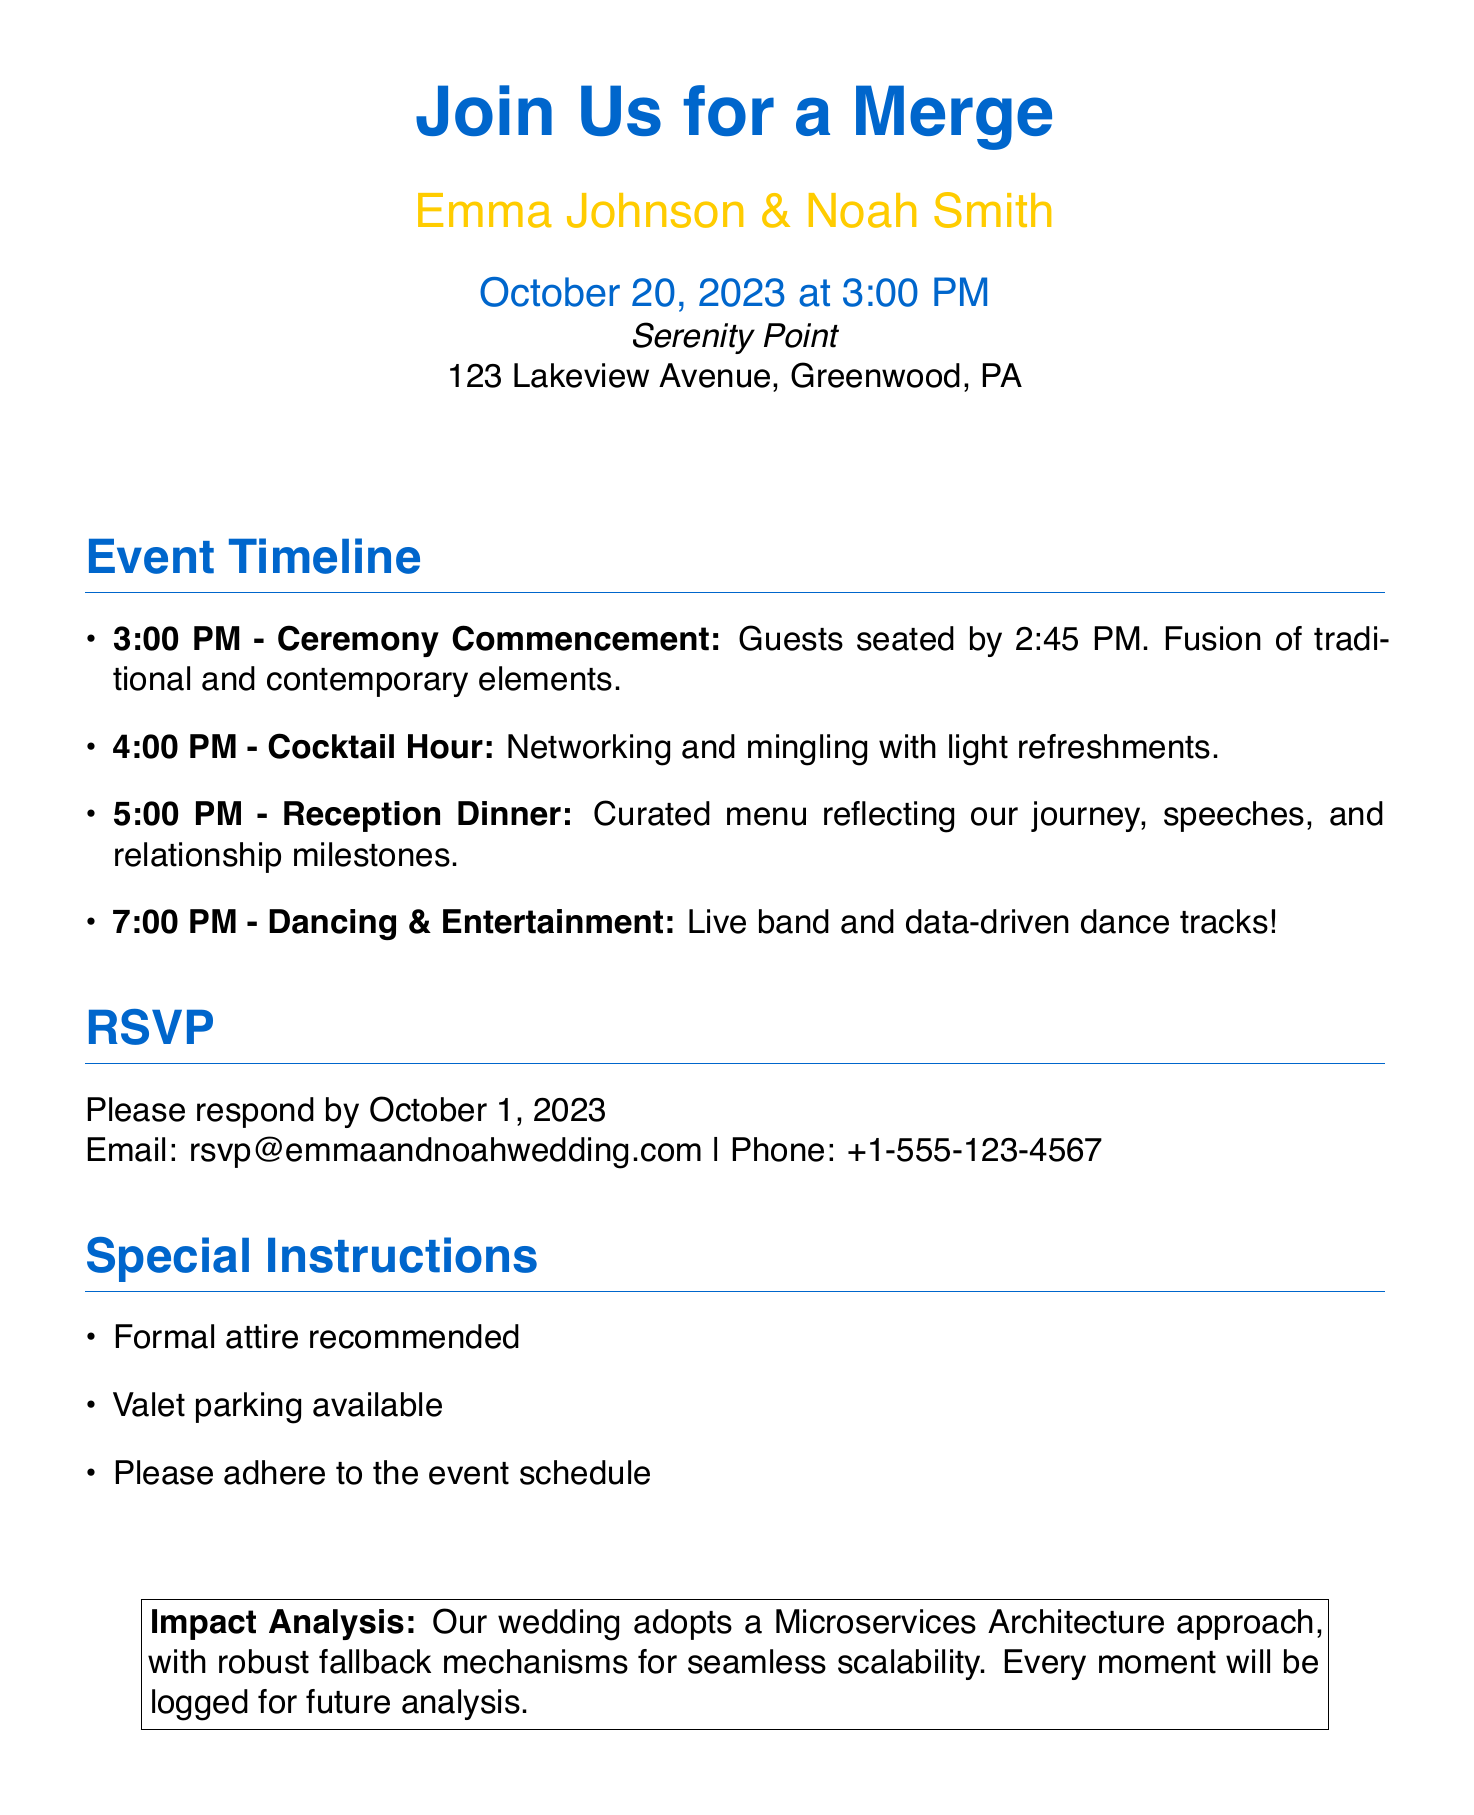What is the date of the wedding? The date of the wedding is stated clearly in the document.
Answer: October 20, 2023 Who are the hosts of the event? The names of the hosts are prominently featured in the invitation.
Answer: Emma Johnson & Noah Smith What time does the ceremony commence? The time for the ceremony start is indicated in the event timeline.
Answer: 3:00 PM What is the location of the wedding? The venue details are provided for the event.
Answer: Serenity Point When is the RSVP deadline? The RSVP deadline is specified in the invitation section.
Answer: October 1, 2023 What type of attire is recommended? The special instructions include recommendations for attire.
Answer: Formal attire How many events are scheduled during the wedding? The event timeline lists distinct activities throughout the day.
Answer: Four What will be featured during the reception dinner? The content of the reception dinner is described in the timeline.
Answer: Curated menu reflecting our journey What approach does the wedding adopt for its structure? The impact analysis section summarizes the architectural approach used for the wedding.
Answer: Microservices Architecture 